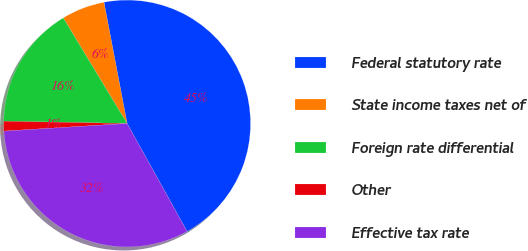<chart> <loc_0><loc_0><loc_500><loc_500><pie_chart><fcel>Federal statutory rate<fcel>State income taxes net of<fcel>Foreign rate differential<fcel>Other<fcel>Effective tax rate<nl><fcel>44.93%<fcel>5.65%<fcel>16.05%<fcel>1.28%<fcel>32.09%<nl></chart> 